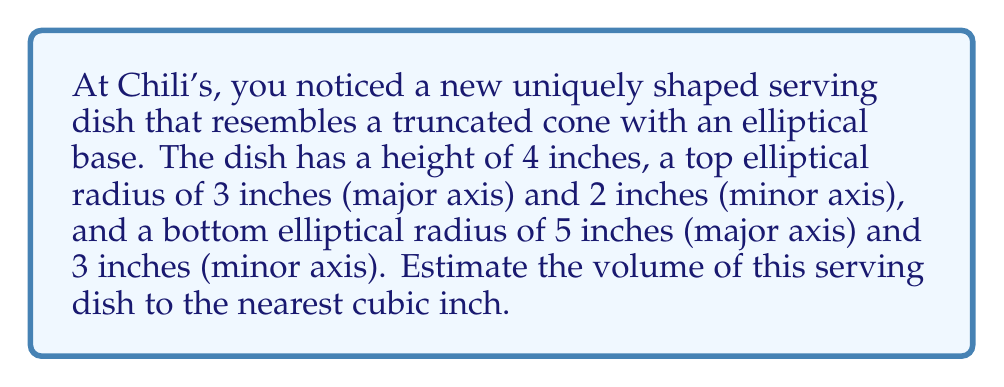What is the answer to this math problem? To estimate the volume of this uniquely shaped serving dish, we can use the formula for the volume of a truncated cone with an elliptical base. The formula is:

$$V = \frac{1}{3}\pi h(a_1b_1 + a_2b_2 + \sqrt{a_1b_1a_2b_2})$$

Where:
$h$ is the height of the dish
$a_1$ and $b_1$ are the semi-major and semi-minor axes of the bottom ellipse
$a_2$ and $b_2$ are the semi-major and semi-minor axes of the top ellipse

Given:
$h = 4$ inches
$a_1 = 5/2 = 2.5$ inches (bottom major semi-axis)
$b_1 = 3/2 = 1.5$ inches (bottom minor semi-axis)
$a_2 = 3/2 = 1.5$ inches (top major semi-axis)
$b_2 = 2/2 = 1$ inch (top minor semi-axis)

Let's substitute these values into the formula:

$$\begin{align}
V &= \frac{1}{3}\pi \cdot 4 \cdot (2.5 \cdot 1.5 + 1.5 \cdot 1 + \sqrt{2.5 \cdot 1.5 \cdot 1.5 \cdot 1}) \\
&= \frac{4\pi}{3} \cdot (3.75 + 1.5 + \sqrt{5.625}) \\
&= \frac{4\pi}{3} \cdot (5.25 + 2.37) \\
&= \frac{4\pi}{3} \cdot 7.62 \\
&= 10.16\pi \\
&\approx 31.92 \text{ cubic inches}
\end{align}$$

Rounding to the nearest cubic inch, we get 32 cubic inches.
Answer: 32 cubic inches 